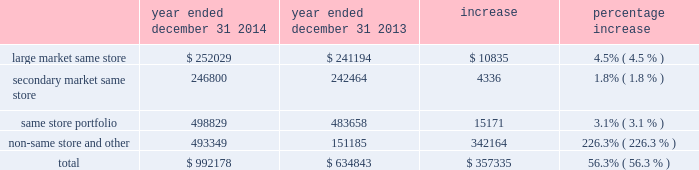Dispositions of depreciable real estate assets excluded from discontinued operations we recorded a gain on sale of depreciable assets excluded from discontinued operations of $ 190.0 million for the year ended december 31 , 2015 , an increase of approximately $ 147.3 million from the $ 42.6 million gain on sale of depreciable assets recorded for the year ended december 31 , 2014 .
The increase was primarily the result of increased disposition activity .
Dispositions increased from eight multifamily properties for the year ended december 31 , 2014 , to 21 multifamily properties for the year ended december 31 , 2015 .
Gain from real estate joint ventures we recorded a gain from real estate joint ventures of $ 6.0 million during the year ended december 31 , 2014 as opposed to no material gain or loss being recorded during the year ended december 31 , 2015 .
The decrease was primarily a result of recording a $ 3.4 million gain for the disposition of ansley village by mid-america multifamily fund ii , or fund ii , as well as a $ 2.8 million gain for the promote fee received from our fund ii partner during 2014 .
The promote fee was received as a result of maa achieving certain performance metrics in its management of the fund ii properties over the life of the joint venture .
There were no such gains recorded during the year ended december 31 , 2015 .
Discontinued operations we recorded a gain on sale of discontinued operations of $ 5.4 million for the year ended december 31 , 2014 .
We did not record a gain or loss on sale of discontinued operations during the year ended december 31 , 2015 , due to the adoption of asu 2014-08 , reporting discontinued operations and disclosures of disposals of components of an entity , which resulted in dispositions being included in the gain on sale of depreciable real estate assets excluded from discontinued operations and is discussed further below .
Net income attributable to noncontrolling interests net income attributable to noncontrolling interests for the year ended december 31 , 2015 was approximately $ 18.5 million , an increase of $ 10.2 million from the year ended december 31 , 2014 .
This increase is consistent with the increase to overall net income and is primarily a result of the items discussed above .
Net income attributable to maa primarily as a result of the items discussed above , net income attributable to maa increased by approximately $ 184.3 million in the year ended december 31 , 2015 from the year ended december 31 , 2014 .
Comparison of the year ended december 31 , 2014 to the year ended december 31 , 2013 the comparison of the year ended december 31 , 2014 to the year ended december 31 , 2013 shows the segment break down based on the 2014 same store portfolios .
A comparison using the 2015 same store portfolio would not be comparative due to the nature of the classifications as a result of the merger .
Property revenues the table shows our property revenues by segment for the years ended december 31 , 2014 and december 31 , 2013 ( dollars in thousands ) : year ended december 31 , 2014 year ended december 31 , 2013 increase percentage increase .
Job title mid-america apartment 10-k revision 1 serial <12345678> date sunday , march 20 , 2016 job number 304352-1 type page no .
51 operator abigaels .
What is the percentage of non-same store revenue among the total revenue in 2014? 
Rationale: it is the revenue of the non-same store divided by the total revenue , then turned into a percentage .
Computations: (493349 / 992178)
Answer: 0.49724. 